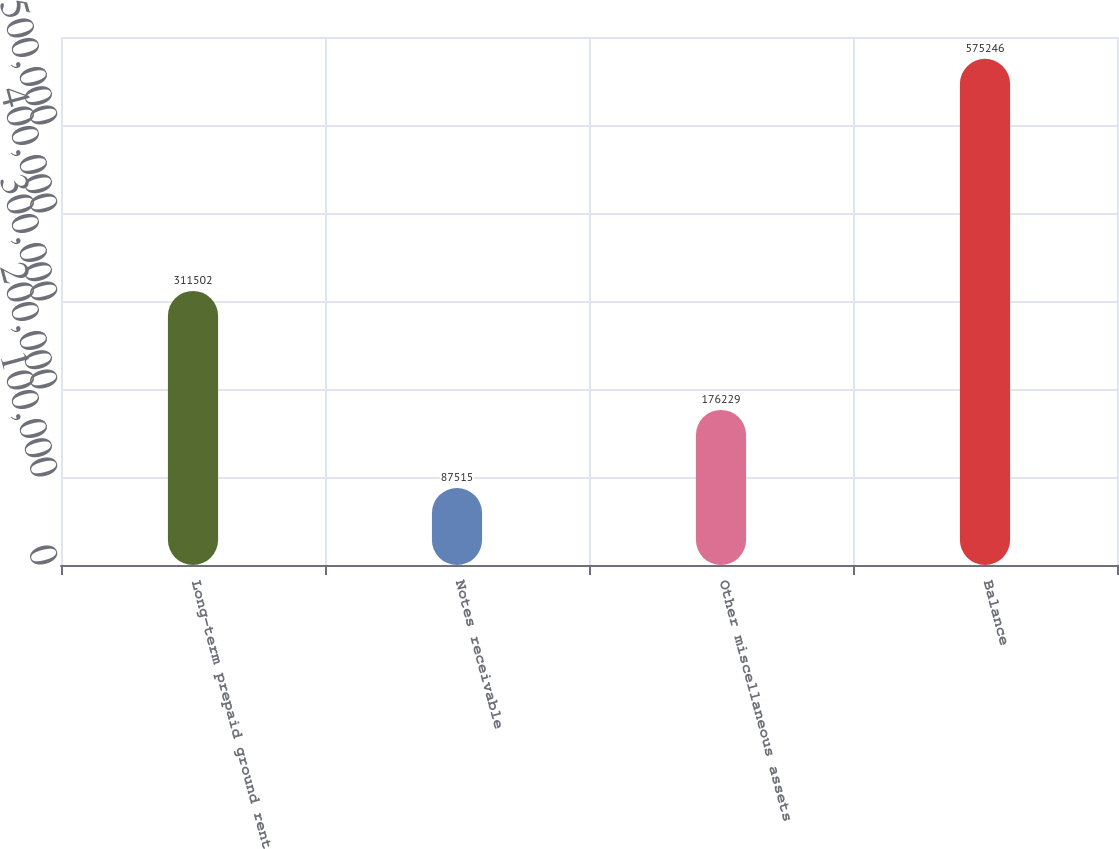<chart> <loc_0><loc_0><loc_500><loc_500><bar_chart><fcel>Long-term prepaid ground rent<fcel>Notes receivable<fcel>Other miscellaneous assets<fcel>Balance<nl><fcel>311502<fcel>87515<fcel>176229<fcel>575246<nl></chart> 